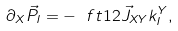<formula> <loc_0><loc_0><loc_500><loc_500>\partial _ { X } \vec { P } _ { I } = - \ f t 1 2 \vec { J } _ { X Y } k ^ { Y } _ { I } ,</formula> 